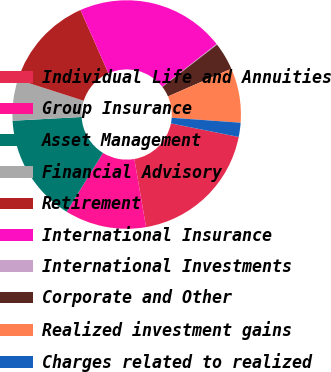<chart> <loc_0><loc_0><loc_500><loc_500><pie_chart><fcel>Individual Life and Annuities<fcel>Group Insurance<fcel>Asset Management<fcel>Financial Advisory<fcel>Retirement<fcel>International Insurance<fcel>International Investments<fcel>Corporate and Other<fcel>Realized investment gains<fcel>Charges related to realized<nl><fcel>19.14%<fcel>11.52%<fcel>15.33%<fcel>5.81%<fcel>13.43%<fcel>21.05%<fcel>0.1%<fcel>3.91%<fcel>7.71%<fcel>2.0%<nl></chart> 